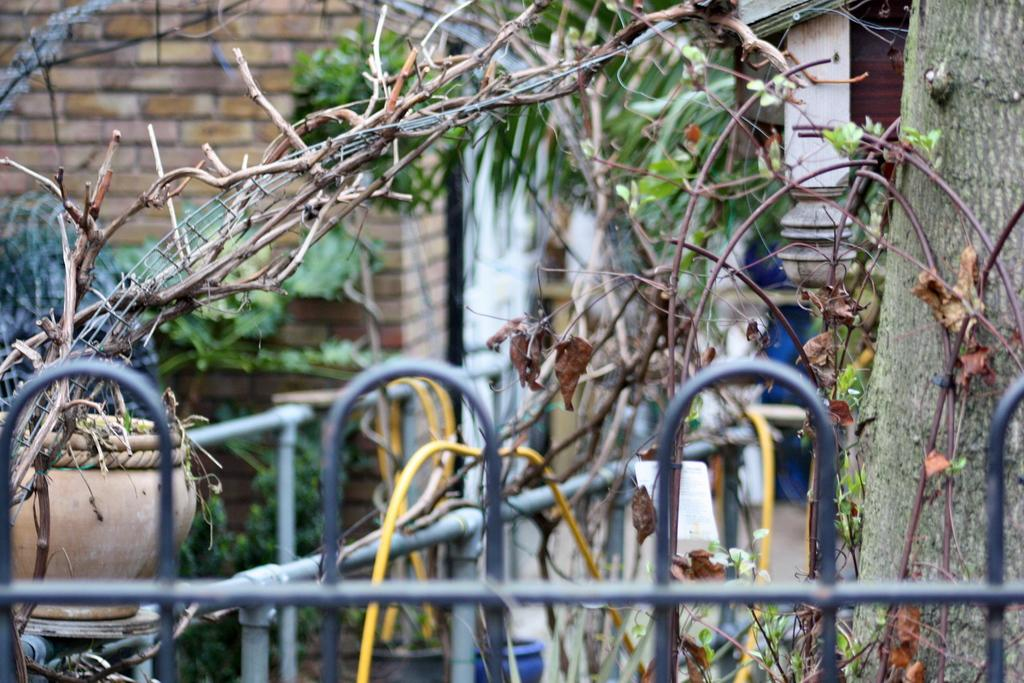What type of plant life is visible in the image? There is a tree and a plant in a pot visible in the image. Can you describe the tree in the image? The tree has bark and branches visible in the image. What is the plant in the pot placed in? The plant in the pot is placed on the ground. What type of structure can be seen in the image? There is a wall visible in the image. What objects are in the foreground of the image? There are metal poles in the foreground of the image. What type of plastic material is covering the tree in the image? There is no plastic material covering the tree in the image; it is a natural tree with bark and branches visible. 